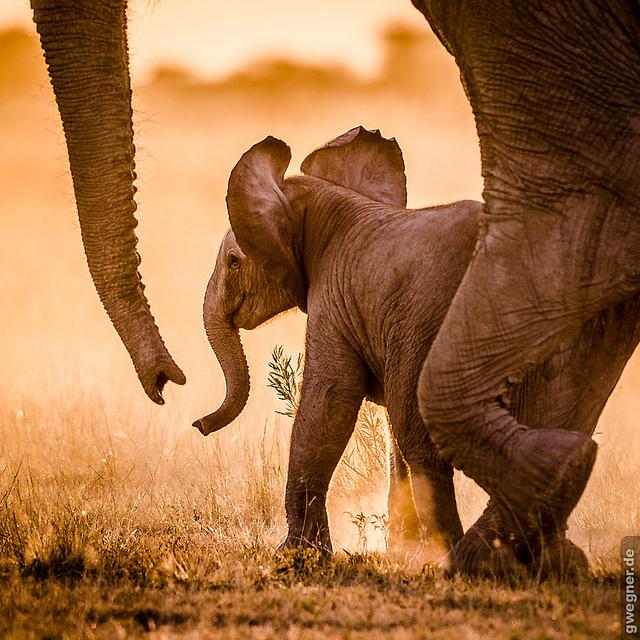What is flopping on the baby elephant?
Concise answer only. Ears. Is that elephant walking with its parent?
Write a very short answer. Yes. Does the baby elephant have tusks?
Write a very short answer. No. 